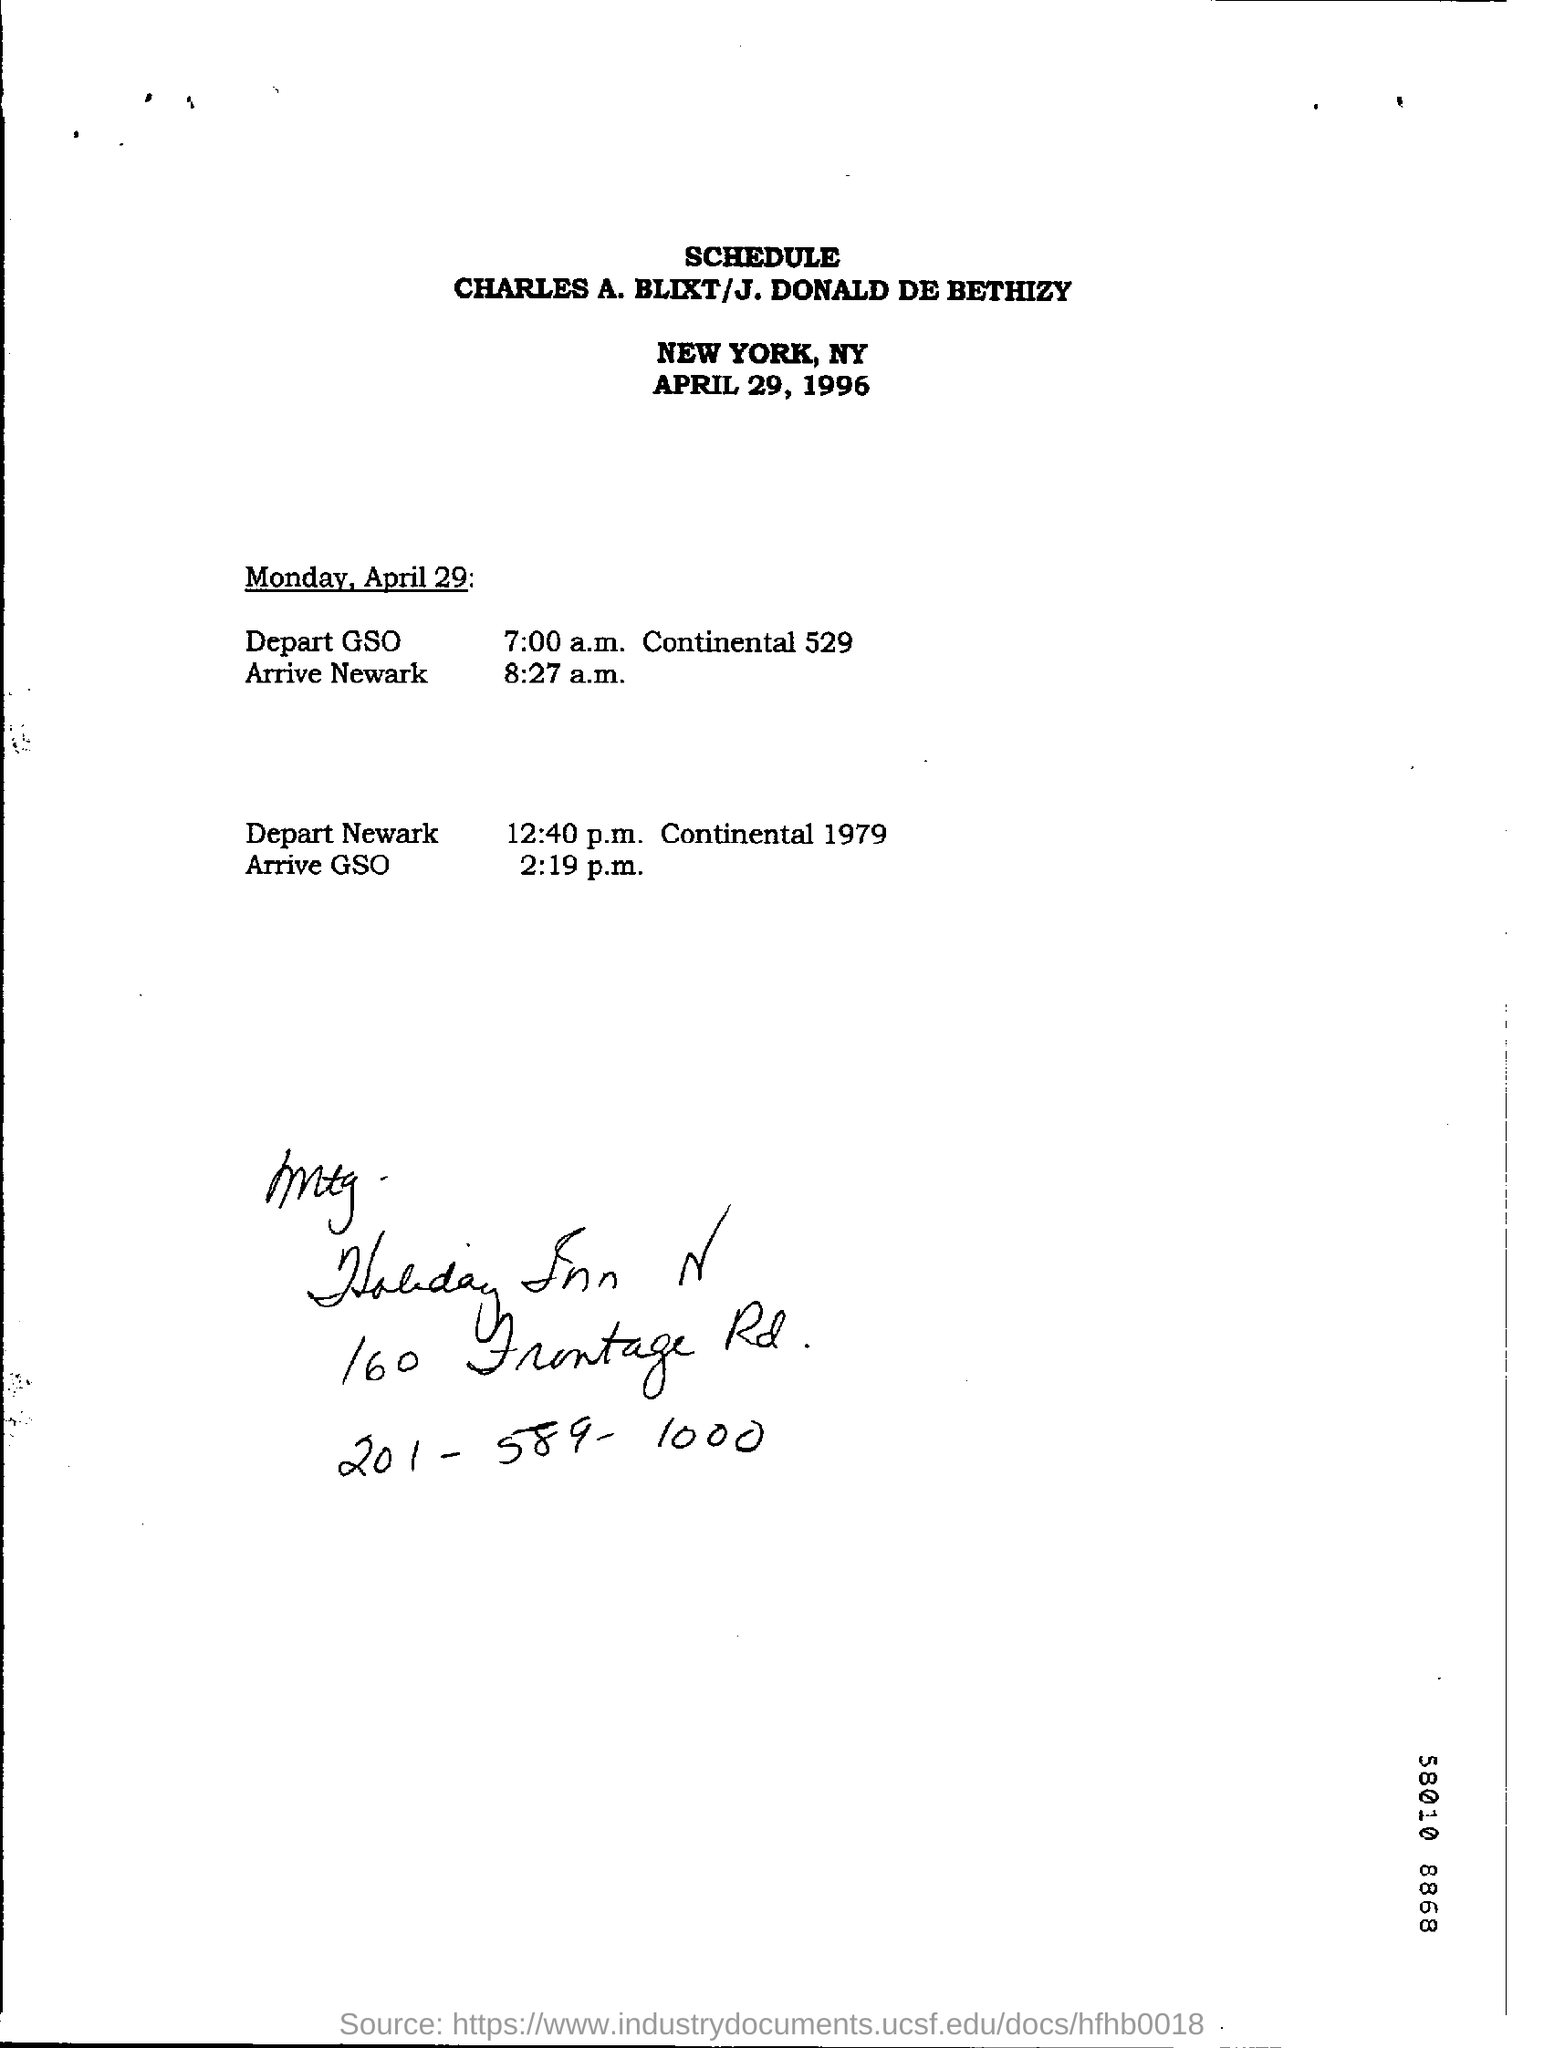Specify some key components in this picture. The arrival at GSO is scheduled for 2:19 p.m. The date on the document is April 29, 1996. The departure from Newark is scheduled to occur at 12:40 p.m. The arrival at Newark is scheduled for 8:27 a.m. 